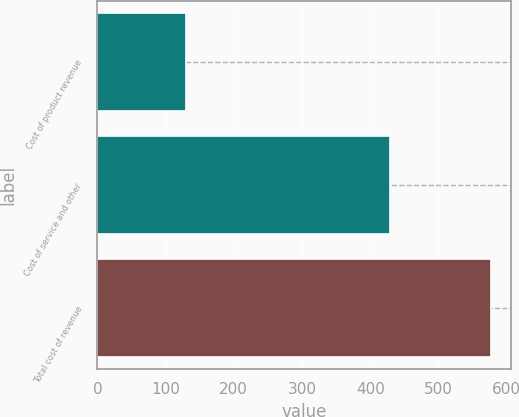Convert chart to OTSL. <chart><loc_0><loc_0><loc_500><loc_500><bar_chart><fcel>Cost of product revenue<fcel>Cost of service and other<fcel>Total cost of revenue<nl><fcel>130<fcel>429<fcel>577<nl></chart> 